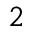Convert formula to latex. <formula><loc_0><loc_0><loc_500><loc_500>^ { 2 }</formula> 